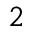Convert formula to latex. <formula><loc_0><loc_0><loc_500><loc_500>^ { 2 }</formula> 